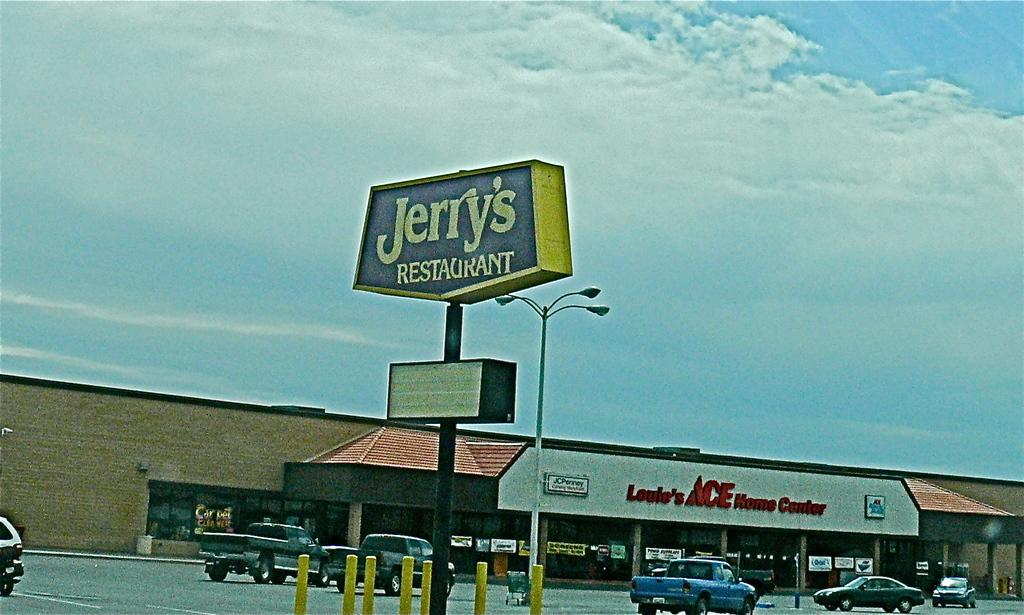Provide a one-sentence caption for the provided image. Sitting in a parking lot of Jerry restaurant with Ace home center in the background. 